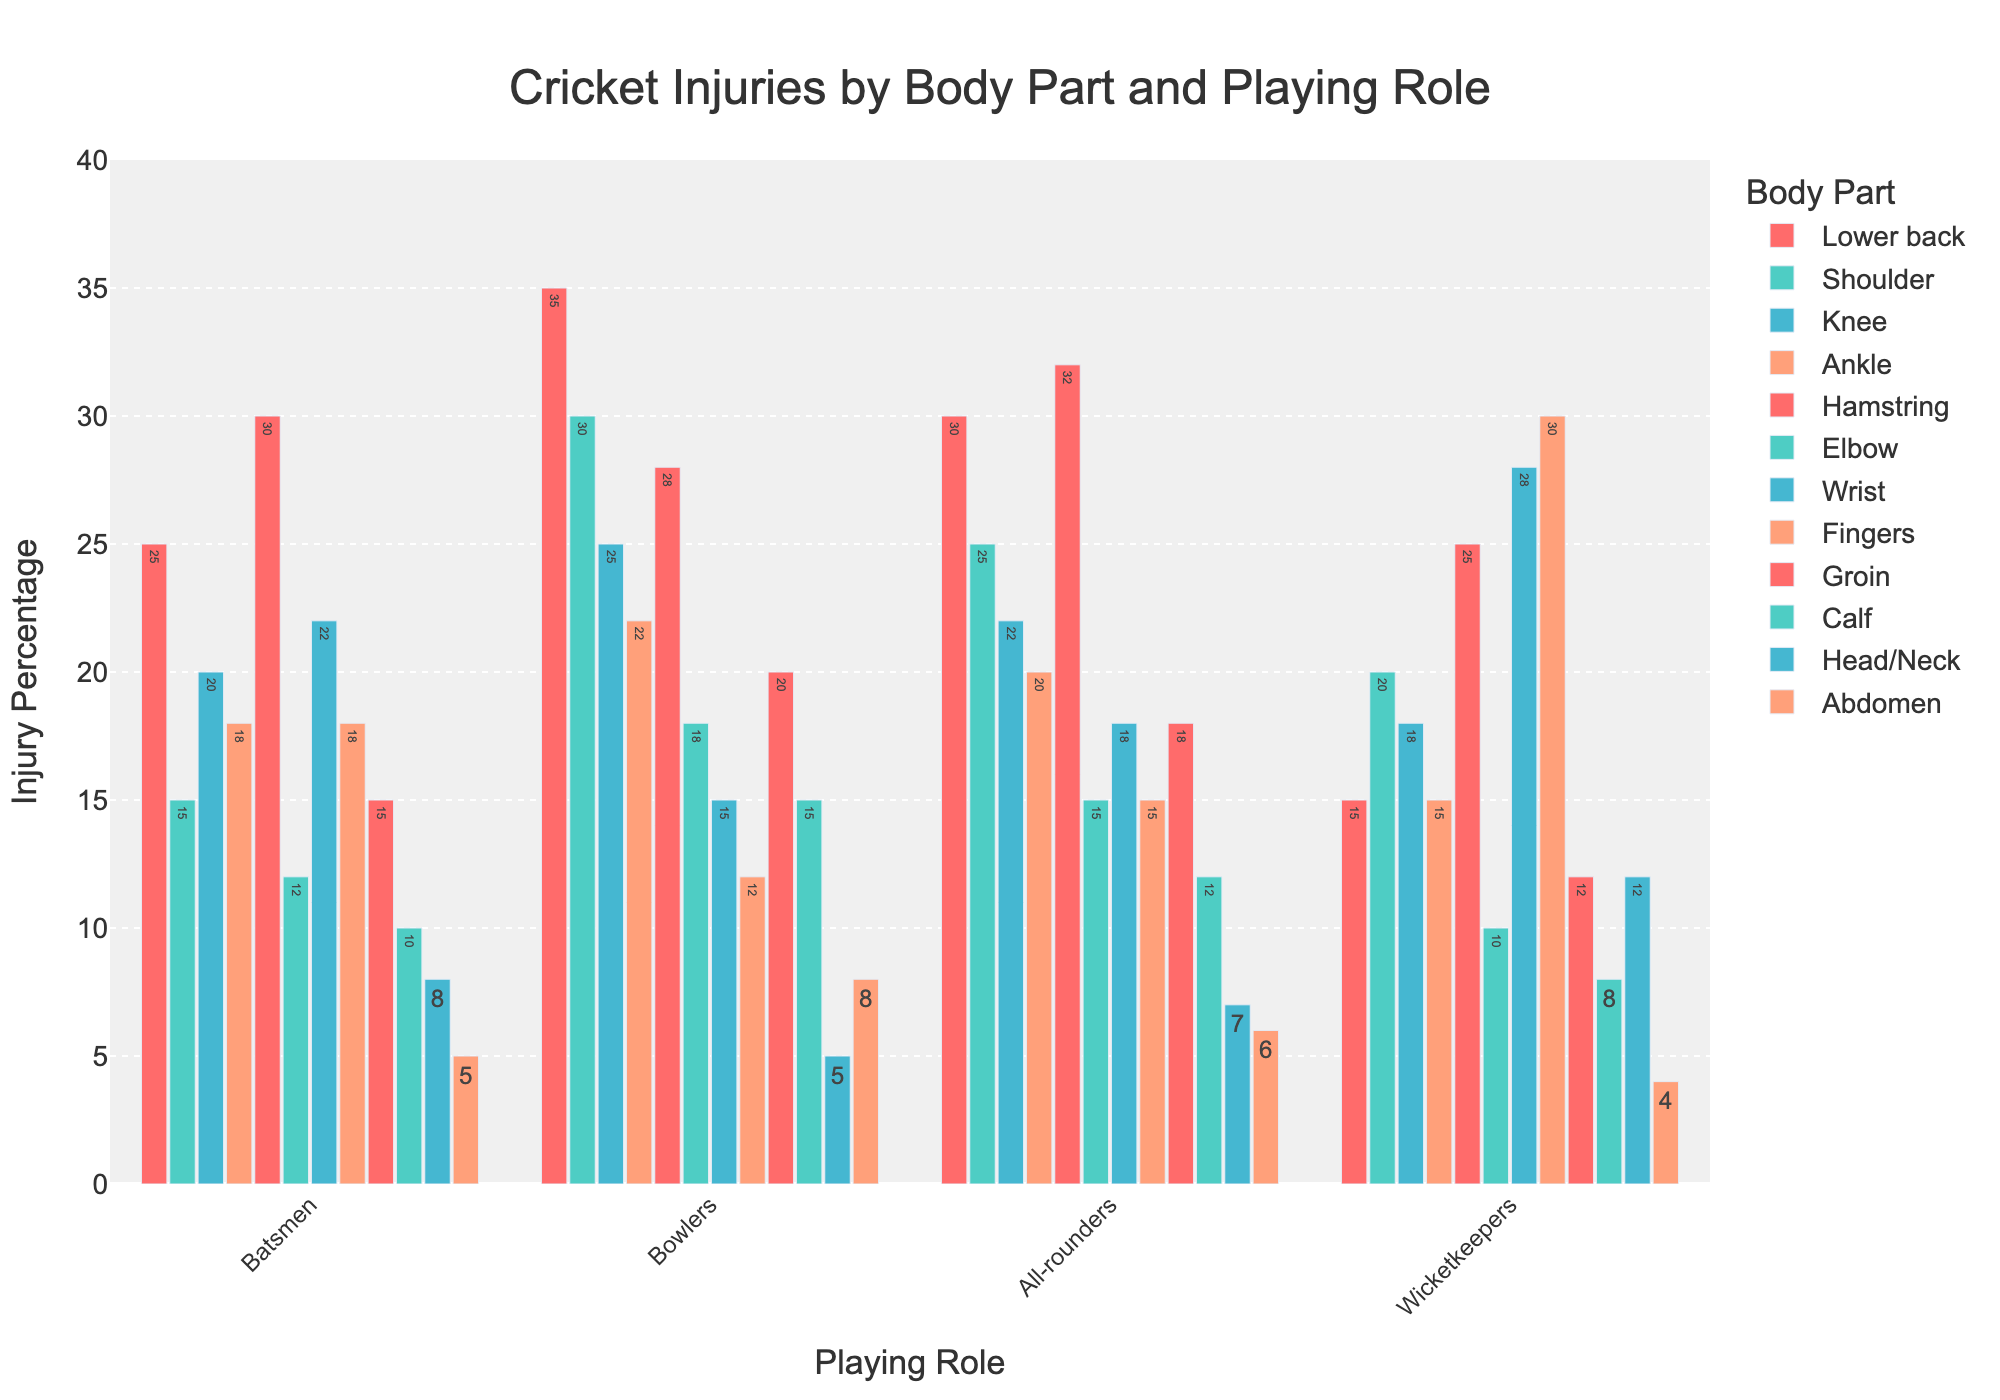Which body part has the highest injury percentage for bowlers? Look at the bar heights in the bowlers category and find the tallest bar. The tallest bar for bowlers corresponds to shoulder injuries.
Answer: Shoulder Which role sees the most hamstring injuries? Compare the heights of the bars for hamstring injuries across all playing roles. The highest bar corresponds to all-rounders.
Answer: All-rounders What's the difference in injury percentage for lower back injuries between bowlers and wicketkeepers? Find the heights of the bars for lower back injuries for both bowlers and wicketkeepers. The bowlers have 35%, and the wicketkeepers have 15%, so the difference is 35% - 15% = 20%.
Answer: 20% Which body part has the least injuries for batsmen? Look for the shortest bar under the batsmen category. The shortest bar corresponds to abdomen injuries, which are at 5%.
Answer: Abdomen Which playing role has the highest injury percentage in wrist injuries? Compare the heights of the bars for wrist injuries across all playing roles. The highest bar is for wicketkeepers.
Answer: Wicketkeepers Are knee injuries more common in all-rounders or batsmen? Compare the heights of the bars for knee injuries between all-rounders and batsmen. All-rounders have a slightly higher bar than batsmen.
Answer: All-rounders Which two body parts have injury percentages closest to each other for wicketkeepers? Compare the heights of the bars for all body parts specific to wicketkeepers, looking for the smallest difference. Shoulder (20%) and groin (12%) have an 8% difference.
Answer: Shoulder and Groin What is the average injury percentage for elbow injuries across all roles? Add the percentages for elbow injuries across all roles and divide by the number of roles: (12 + 18 + 15 + 10) / 4 = 55 / 4 = 13.75%
Answer: 13.75% Which body part has more injuries for bowlers, the ankle or the calf? Compare the bar heights for ankle and calf injuries in the bowlers category. Bowlers have more injuries in the ankle (22%) compared to the calf (15%).
Answer: Ankle Is there a body part where wicketkeepers have the highest injury percentage compared to all other roles? Look across the roles for each body part, and see if wicketkeepers have the tallest bar in any of them. Wicketkeepers have the highest injury percentage for fingers (30%) and wrist injuries (28%) compared to other roles.
Answer: Fingers and Wrist 